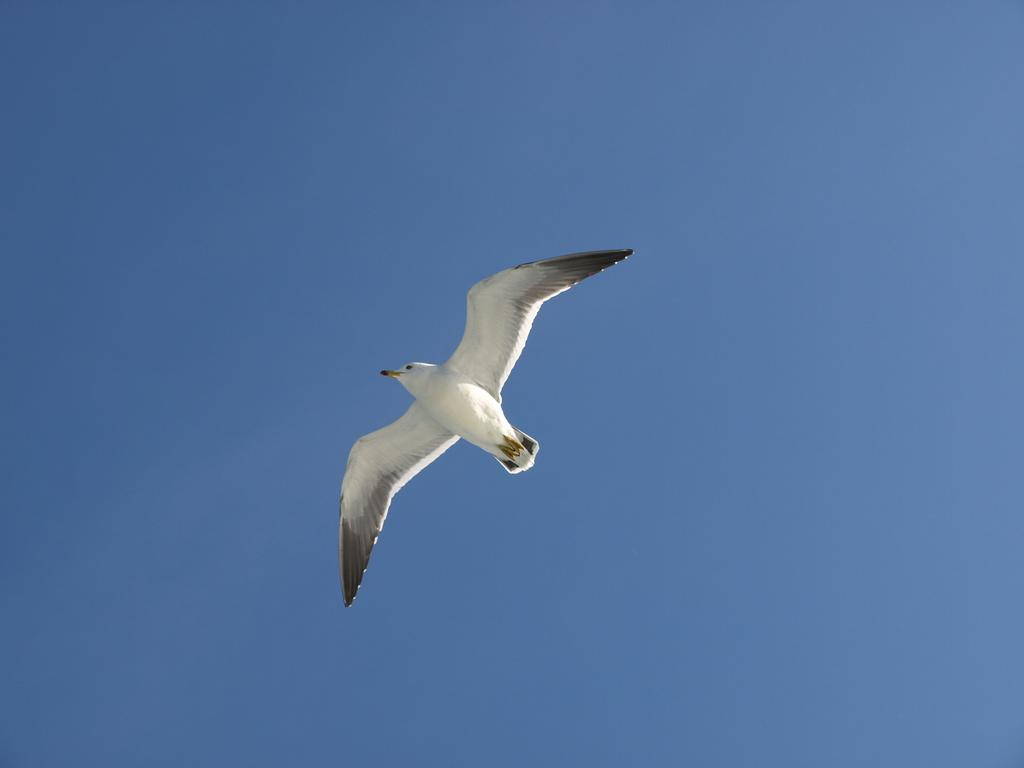What is the main subject in the foreground of the image? There is a bird in the foreground of the image. What is the bird doing in the image? The bird is flying in the air. What can be seen in the background of the image? The sky is visible in the background of the image. What type of crime is being committed in the image? There is no crime present in the image; it features a bird flying in the air. What kind of wren can be seen in the image? There is no specific type of wren mentioned or depicted in the image; it simply shows a bird flying. 